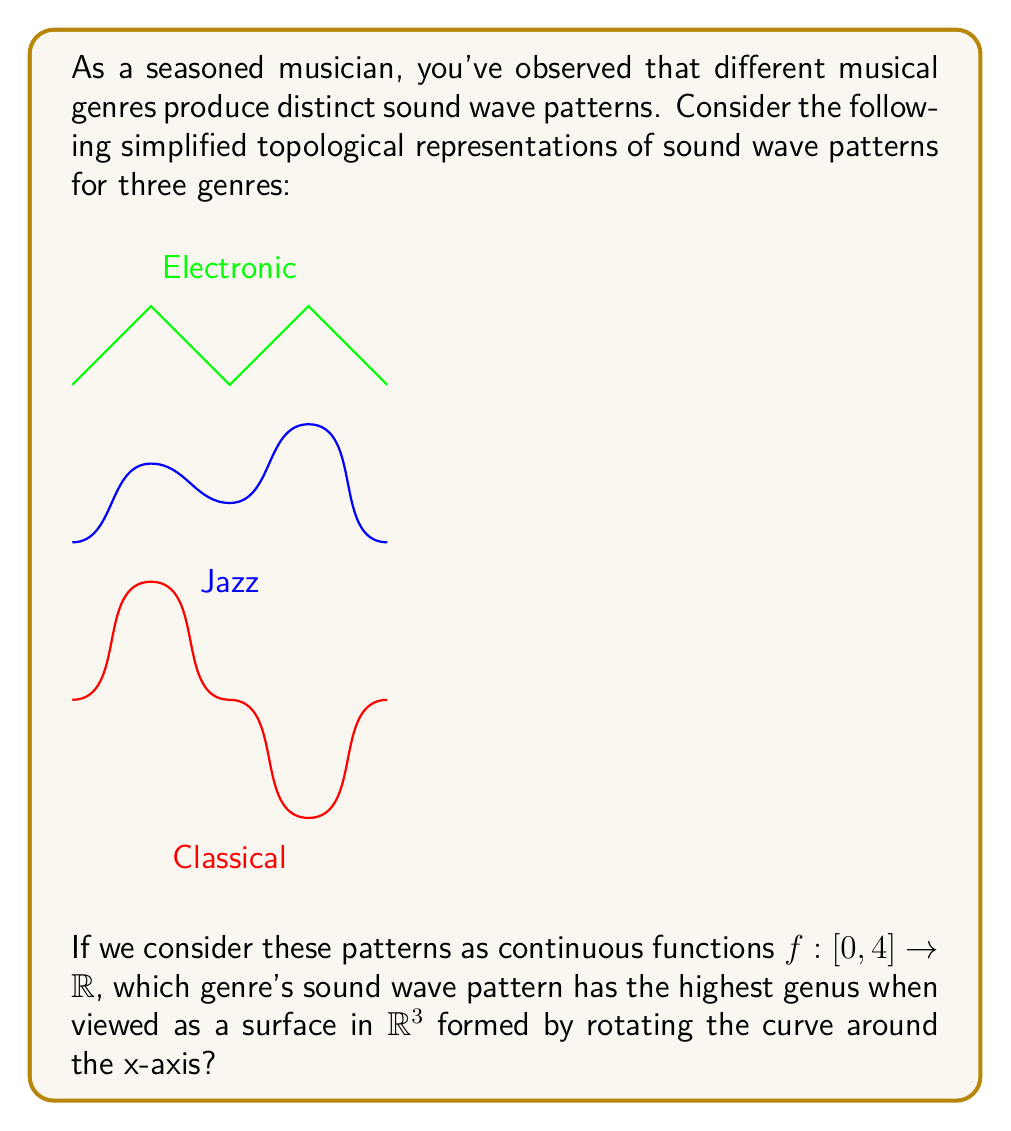Can you answer this question? To solve this problem, we need to understand the concept of genus in topology and how it relates to the given sound wave patterns:

1) The genus of a surface is the maximum number of cuts along non-intersecting closed simple curves without rendering the resultant manifold disconnected. For surfaces of revolution, this corresponds to the number of "holes" in the object.

2) When we rotate a curve around the x-axis, each time the curve crosses the x-axis, it creates a "hole" in the resulting surface.

3) Let's analyze each genre:

   Classical: The curve crosses the x-axis 3 times, creating 2 "holes".
   Jazz: The curve never crosses the x-axis, creating 0 "holes".
   Electronic: The curve crosses the x-axis 4 times, creating 3 "holes".

4) The genus of each surface is equal to the number of "holes":

   Classical: genus = 2
   Jazz: genus = 0
   Electronic: genus = 3

5) Therefore, the electronic music pattern, when rotated around the x-axis, creates a surface with the highest genus.

It's worth noting that real sound waves are much more complex, and this is a simplified representation for topological analysis.
Answer: Electronic (genus = 3) 